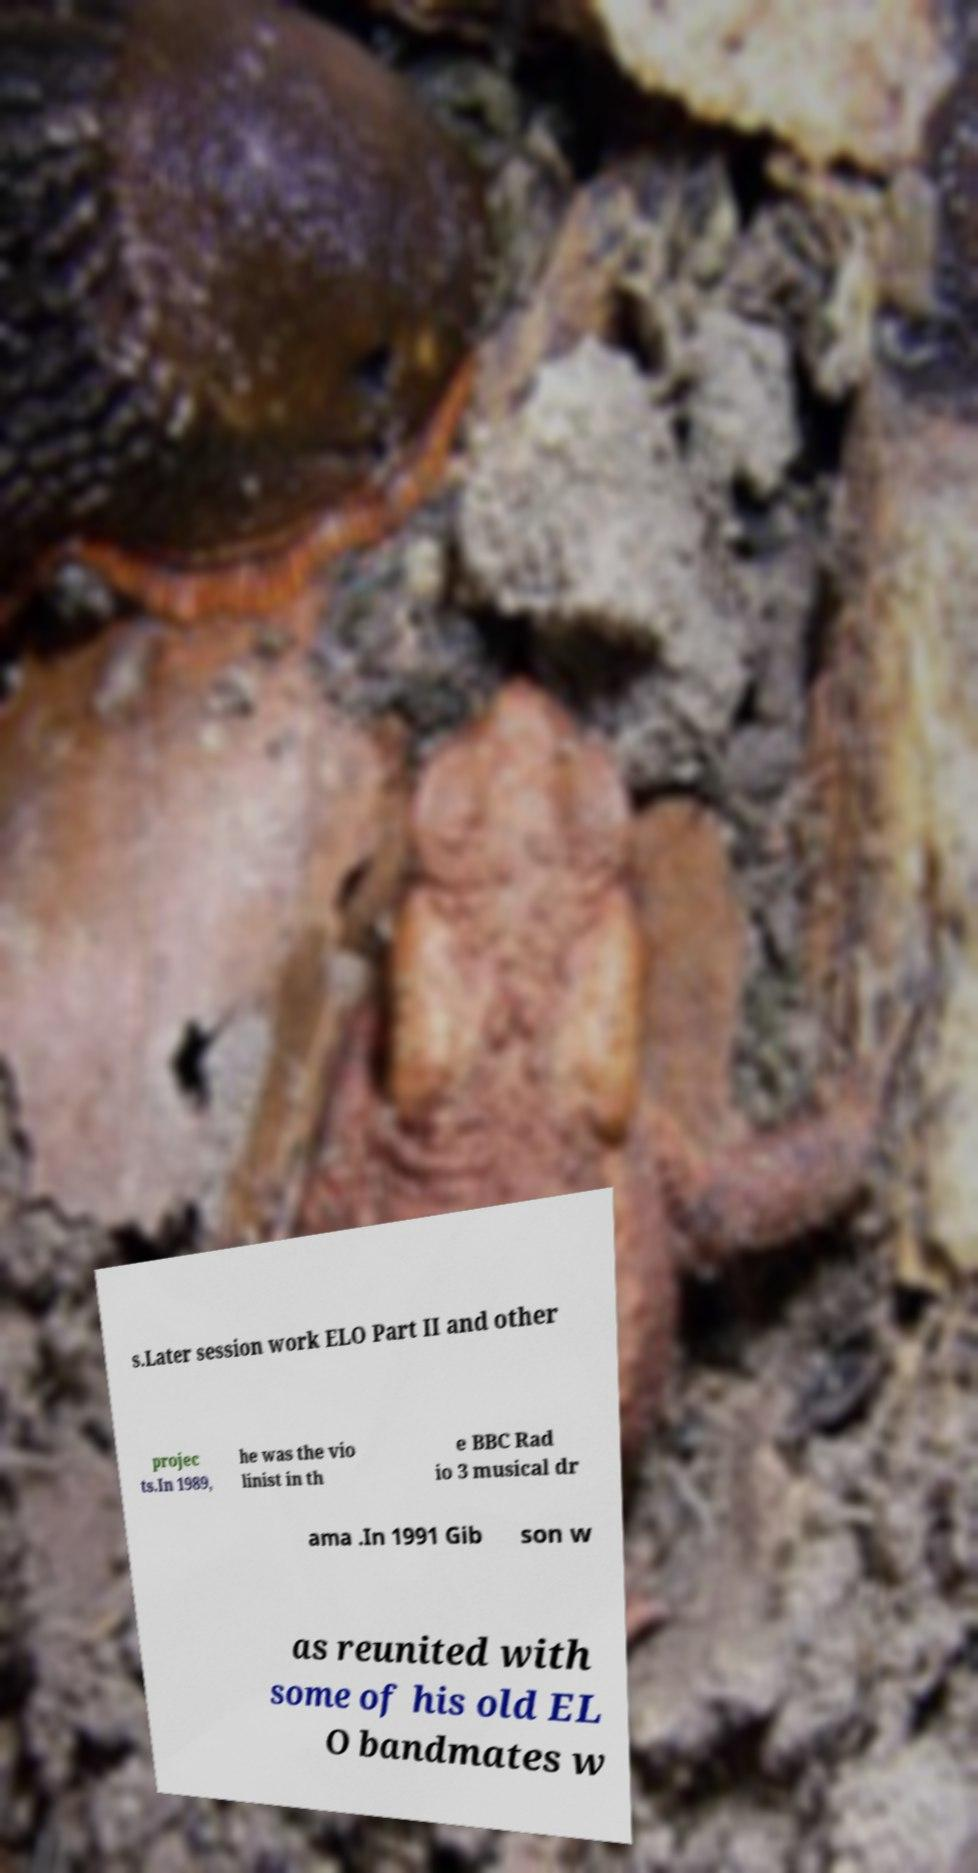Can you accurately transcribe the text from the provided image for me? s.Later session work ELO Part II and other projec ts.In 1989, he was the vio linist in th e BBC Rad io 3 musical dr ama .In 1991 Gib son w as reunited with some of his old EL O bandmates w 